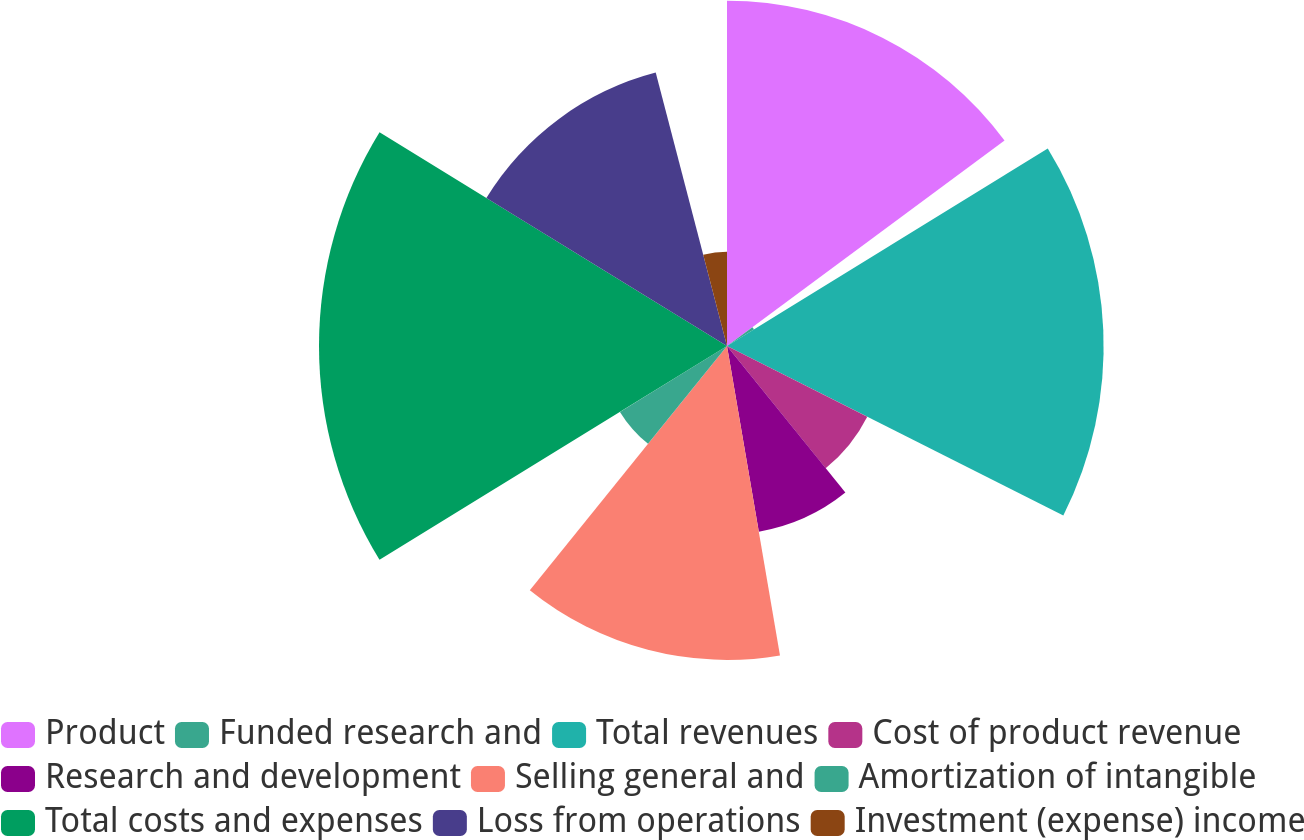Convert chart. <chart><loc_0><loc_0><loc_500><loc_500><pie_chart><fcel>Product<fcel>Funded research and<fcel>Total revenues<fcel>Cost of product revenue<fcel>Research and development<fcel>Selling general and<fcel>Amortization of intangible<fcel>Total costs and expenses<fcel>Loss from operations<fcel>Investment (expense) income<nl><fcel>14.86%<fcel>1.36%<fcel>16.21%<fcel>6.76%<fcel>8.11%<fcel>13.51%<fcel>5.41%<fcel>17.56%<fcel>12.16%<fcel>4.06%<nl></chart> 